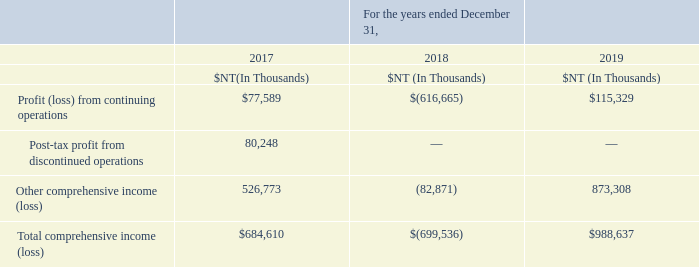Financial information of associates and joint ventures:
There is no individually significant associate or joint venture for the Company. For individually immaterial associates and joint ventures, the following tables summarize the amount recognized by the Company at its share of those associates and joint ventures separately.
When an associate or a joint venture is a foreign operation, and the functional currency of the foreign entity is different from the Company, an exchange difference arising from translation of the foreign entity will be recognized in other comprehensive income (loss).
Such exchange differences recognized in other comprehensive income (loss) in the financial statements for the years ended December 31, 2017, 2018 and 2019 were NT$45 million, NT$(16) million and NT$(9) million, respectively, which were not included in the following table.
The aggregate amount of the Company’s share of all its individually immaterial associates that are accounted for using the equity method was as follows:
Is there a  individually significant associate or joint venture for the Company? There is no individually significant associate or joint venture for the company. What is recognized as comprehensive income (loss)? An exchange difference arising from translation of the foreign entity will be recognized in other comprehensive income (loss). What method is used to calculate the aggregate amount of the Company’s share? The equity method. What is the average Profit (loss) from continuing operations?
Answer scale should be: thousand. (77,589+616,665+115,329) / 3
Answer: 269861. What is the increase/ (decrease) in Total comprehensive income (loss) from 2018 to 2019?
Answer scale should be: thousand. 988,637-699,536
Answer: 289101. What is the increase/ (decrease) in Profit (loss) from continuing operations from 2018 to 2019?
Answer scale should be: thousand. 115,329-616,665
Answer: -501336. 